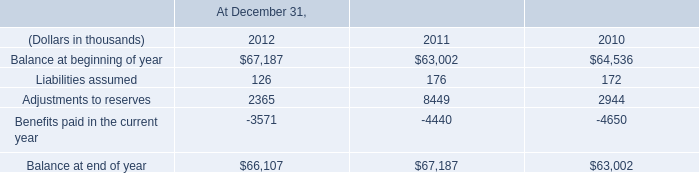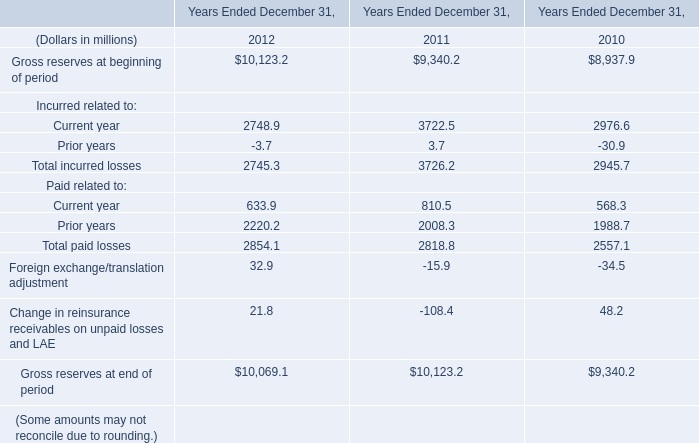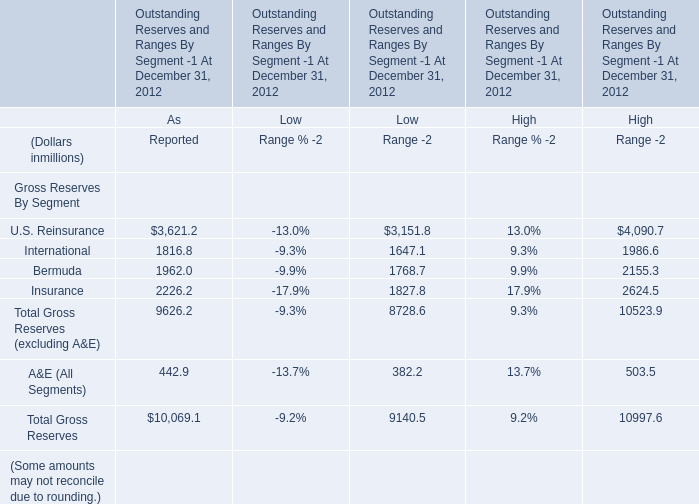What is the ratio of all elements that are smaller than 2000 to the sum of elements for for As Reported? 
Computations: (((1816.8 + 1962) + 442.9) / 10069.1)
Answer: 0.41927. 